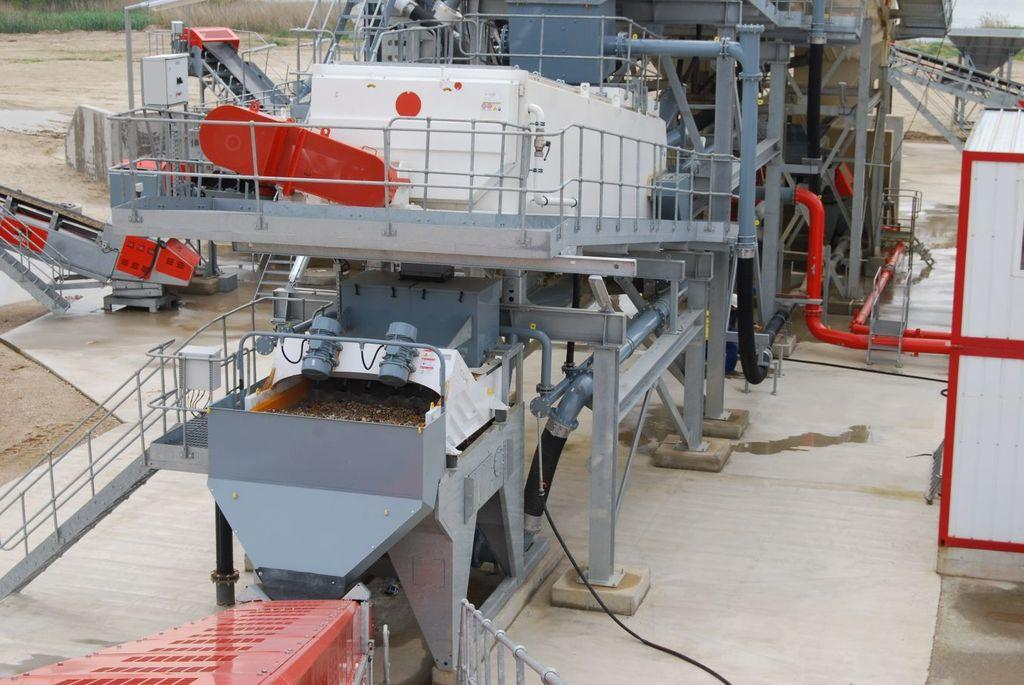What type of equipment or machinery is present in the image? There are machines with pipes and railings in the center of the image. What can be seen in the background of the image? There is grass and sand in the background of the image. Where is the dad sitting in the image? There is no dad present in the image. What is the value of the quarter in the image? There is no quarter present in the image. 